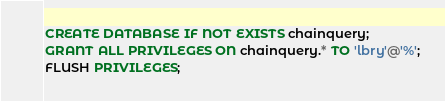Convert code to text. <code><loc_0><loc_0><loc_500><loc_500><_SQL_>CREATE DATABASE IF NOT EXISTS chainquery;
GRANT ALL PRIVILEGES ON chainquery.* TO 'lbry'@'%';
FLUSH PRIVILEGES;</code> 